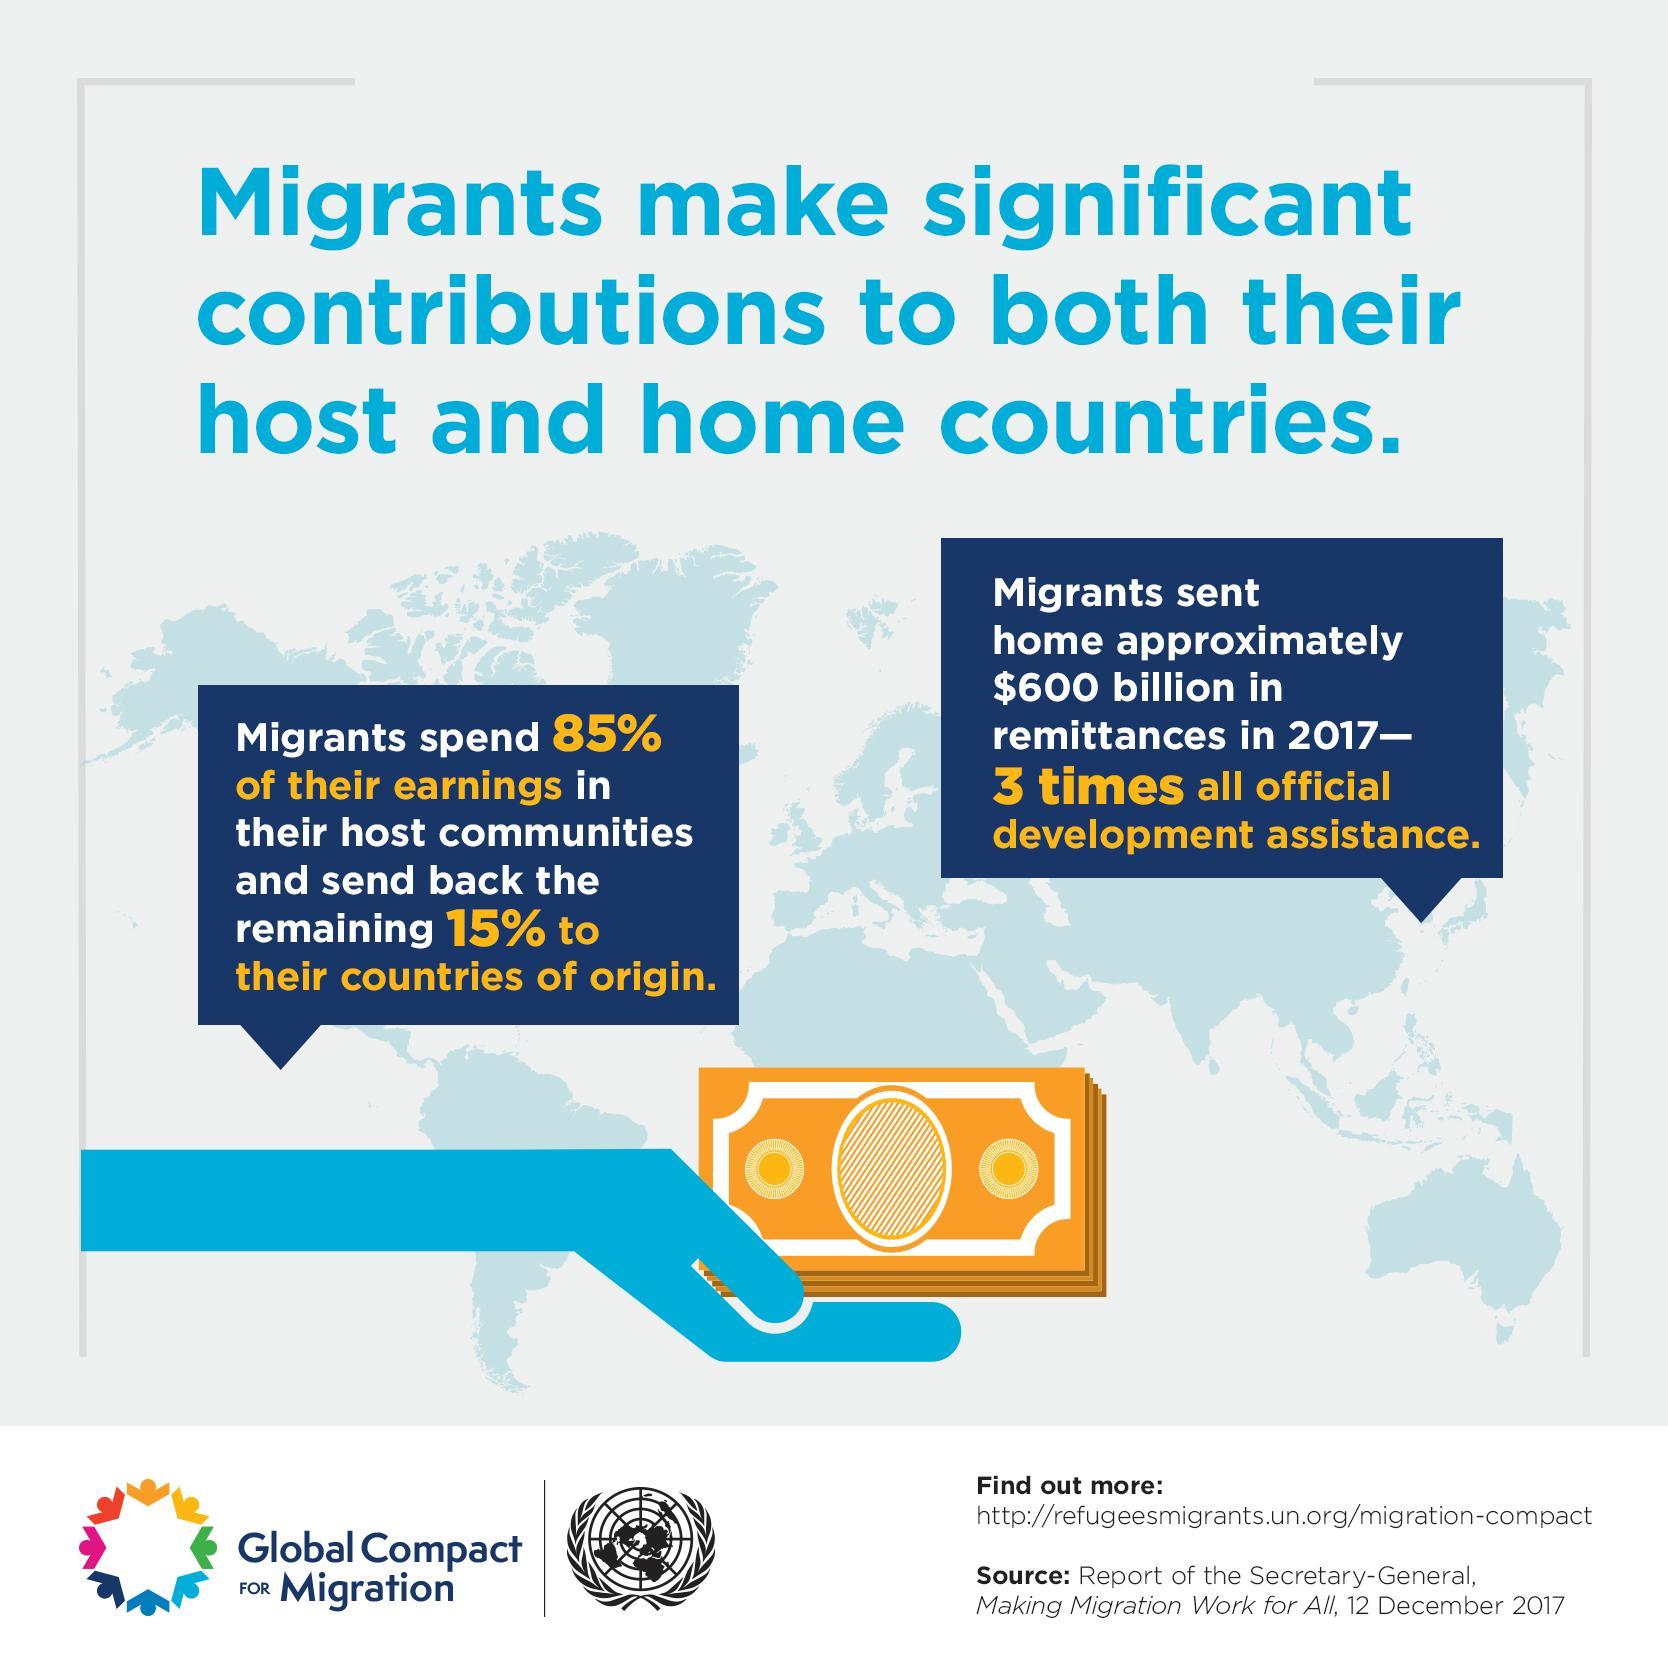List a handful of essential elements in this visual. Approximately 15% of the migrants' earnings are sent to their countries of origin. A recent study found that migrants typically spend 85% of their earnings in their host country. The color of currency notes is yellow. The community being discussed is the one dealing with migrants. 